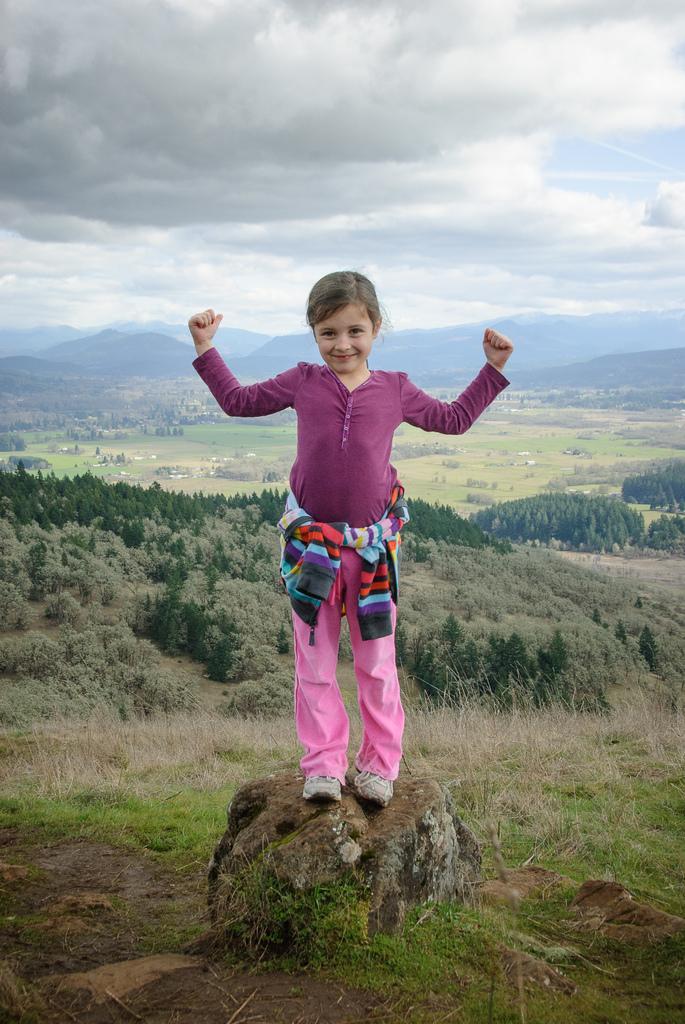Could you give a brief overview of what you see in this image? In this image there is a girl standing on the stone. In the background there are trees and small plants. At the top there is sky with the clouds. There are hills at the backside. 